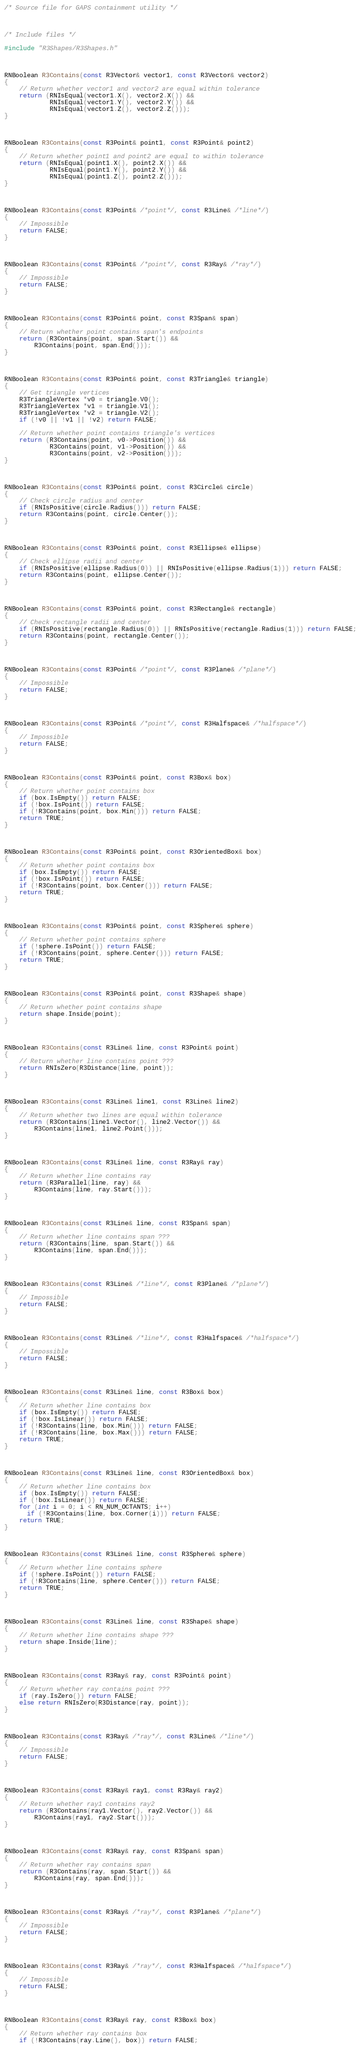<code> <loc_0><loc_0><loc_500><loc_500><_C++_>/* Source file for GAPS containment utility */



/* Include files */

#include "R3Shapes/R3Shapes.h"



RNBoolean R3Contains(const R3Vector& vector1, const R3Vector& vector2)
{
    // Return whether vector1 and vector2 are equal within tolerance
    return (RNIsEqual(vector1.X(), vector2.X()) &&
            RNIsEqual(vector1.Y(), vector2.Y()) &&
            RNIsEqual(vector1.Z(), vector2.Z()));
}



RNBoolean R3Contains(const R3Point& point1, const R3Point& point2)
{
    // Return whether point1 and point2 are equal to within tolerance
    return (RNIsEqual(point1.X(), point2.X()) &&
            RNIsEqual(point1.Y(), point2.Y()) &&
            RNIsEqual(point1.Z(), point2.Z()));
}



RNBoolean R3Contains(const R3Point& /*point*/, const R3Line& /*line*/)
{
    // Impossible
    return FALSE;
}



RNBoolean R3Contains(const R3Point& /*point*/, const R3Ray& /*ray*/)
{
    // Impossible
    return FALSE;
}



RNBoolean R3Contains(const R3Point& point, const R3Span& span)
{
    // Return whether point contains span's endpoints
    return (R3Contains(point, span.Start()) && 
	    R3Contains(point, span.End()));
}



RNBoolean R3Contains(const R3Point& point, const R3Triangle& triangle)
{
    // Get triangle vertices
    R3TriangleVertex *v0 = triangle.V0();
    R3TriangleVertex *v1 = triangle.V1();
    R3TriangleVertex *v2 = triangle.V2();
    if (!v0 || !v1 || !v2) return FALSE;

    // Return whether point contains triangle's vertices
    return (R3Contains(point, v0->Position()) &&
            R3Contains(point, v1->Position()) &&
            R3Contains(point, v2->Position())); 
}



RNBoolean R3Contains(const R3Point& point, const R3Circle& circle)
{
    // Check circle radius and center
    if (RNIsPositive(circle.Radius())) return FALSE;
    return R3Contains(point, circle.Center());
}



RNBoolean R3Contains(const R3Point& point, const R3Ellipse& ellipse)
{
    // Check ellipse radii and center
    if (RNIsPositive(ellipse.Radius(0)) || RNIsPositive(ellipse.Radius(1))) return FALSE;
    return R3Contains(point, ellipse.Center());
}



RNBoolean R3Contains(const R3Point& point, const R3Rectangle& rectangle)
{
    // Check rectangle radii and center
    if (RNIsPositive(rectangle.Radius(0)) || RNIsPositive(rectangle.Radius(1))) return FALSE;
    return R3Contains(point, rectangle.Center());
}



RNBoolean R3Contains(const R3Point& /*point*/, const R3Plane& /*plane*/)
{
    // Impossible
    return FALSE;
}



RNBoolean R3Contains(const R3Point& /*point*/, const R3Halfspace& /*halfspace*/)
{
    // Impossible
    return FALSE;
}



RNBoolean R3Contains(const R3Point& point, const R3Box& box)
{
    // Return whether point contains box
    if (box.IsEmpty()) return FALSE;
    if (!box.IsPoint()) return FALSE;
    if (!R3Contains(point, box.Min())) return FALSE;
    return TRUE;
}



RNBoolean R3Contains(const R3Point& point, const R3OrientedBox& box)
{
    // Return whether point contains box
    if (box.IsEmpty()) return FALSE;
    if (!box.IsPoint()) return FALSE;
    if (!R3Contains(point, box.Center())) return FALSE;
    return TRUE;
}



RNBoolean R3Contains(const R3Point& point, const R3Sphere& sphere)
{
    // Return whether point contains sphere
    if (!sphere.IsPoint()) return FALSE;
    if (!R3Contains(point, sphere.Center())) return FALSE;
    return TRUE;
}



RNBoolean R3Contains(const R3Point& point, const R3Shape& shape)
{
    // Return whether point contains shape
    return shape.Inside(point);
}



RNBoolean R3Contains(const R3Line& line, const R3Point& point)
{
    // Return whether line contains point ???
    return RNIsZero(R3Distance(line, point));
}



RNBoolean R3Contains(const R3Line& line1, const R3Line& line2)
{
    // Return whether two lines are equal within tolerance
    return (R3Contains(line1.Vector(), line2.Vector()) &&
	    R3Contains(line1, line2.Point()));
}



RNBoolean R3Contains(const R3Line& line, const R3Ray& ray)
{
    // Return whether line contains ray
    return (R3Parallel(line, ray) &&
	    R3Contains(line, ray.Start()));
}



RNBoolean R3Contains(const R3Line& line, const R3Span& span)
{
    // Return whether line contains span ???
    return (R3Contains(line, span.Start()) &&
	    R3Contains(line, span.End()));
}



RNBoolean R3Contains(const R3Line& /*line*/, const R3Plane& /*plane*/)
{
    // Impossible
    return FALSE;
}



RNBoolean R3Contains(const R3Line& /*line*/, const R3Halfspace& /*halfspace*/)
{
    // Impossible
    return FALSE;
}



RNBoolean R3Contains(const R3Line& line, const R3Box& box)
{
    // Return whether line contains box 
    if (box.IsEmpty()) return FALSE;
    if (!box.IsLinear()) return FALSE;
    if (!R3Contains(line, box.Min())) return FALSE;
    if (!R3Contains(line, box.Max())) return FALSE;
    return TRUE;
}



RNBoolean R3Contains(const R3Line& line, const R3OrientedBox& box)
{
    // Return whether line contains box 
    if (box.IsEmpty()) return FALSE;
    if (!box.IsLinear()) return FALSE;
    for (int i = 0; i < RN_NUM_OCTANTS; i++) 
      if (!R3Contains(line, box.Corner(i))) return FALSE;
    return TRUE;
}



RNBoolean R3Contains(const R3Line& line, const R3Sphere& sphere)
{
    // Return whether line contains sphere 
    if (!sphere.IsPoint()) return FALSE;
    if (!R3Contains(line, sphere.Center())) return FALSE;
    return TRUE;
}



RNBoolean R3Contains(const R3Line& line, const R3Shape& shape)
{
    // Return whether line contains shape ???
    return shape.Inside(line);
}



RNBoolean R3Contains(const R3Ray& ray, const R3Point& point)
{
    // Return whether ray contains point ???
    if (ray.IsZero()) return FALSE;
    else return RNIsZero(R3Distance(ray, point));
}



RNBoolean R3Contains(const R3Ray& /*ray*/, const R3Line& /*line*/)
{
    // Impossible
    return FALSE;
}



RNBoolean R3Contains(const R3Ray& ray1, const R3Ray& ray2)
{
    // Return whether ray1 contains ray2
    return (R3Contains(ray1.Vector(), ray2.Vector()) &&
	    R3Contains(ray1, ray2.Start()));
}



RNBoolean R3Contains(const R3Ray& ray, const R3Span& span)
{
    // Return whether ray contains span
    return (R3Contains(ray, span.Start()) &&
	    R3Contains(ray, span.End()));
}



RNBoolean R3Contains(const R3Ray& /*ray*/, const R3Plane& /*plane*/)
{
    // Impossible
    return FALSE;
}



RNBoolean R3Contains(const R3Ray& /*ray*/, const R3Halfspace& /*halfspace*/)
{
    // Impossible
    return FALSE;
}



RNBoolean R3Contains(const R3Ray& ray, const R3Box& box)
{
    // Return whether ray contains box
    if (!R3Contains(ray.Line(), box)) return FALSE;</code> 